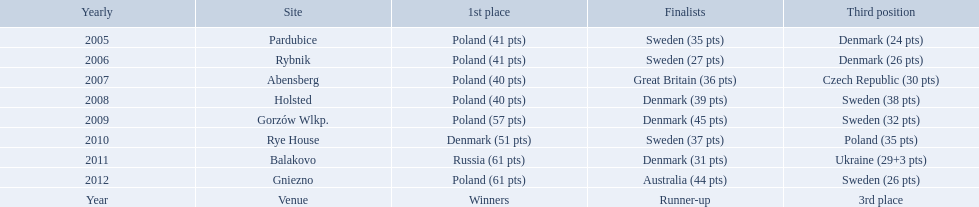After enjoying five consecutive victories at the team speedway junior world championship poland was finally unseated in what year? 2010. In that year, what teams placed first through third? Denmark (51 pts), Sweden (37 pts), Poland (35 pts). Which of those positions did poland specifically place in? 3rd place. 